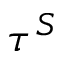<formula> <loc_0><loc_0><loc_500><loc_500>\tau ^ { S }</formula> 